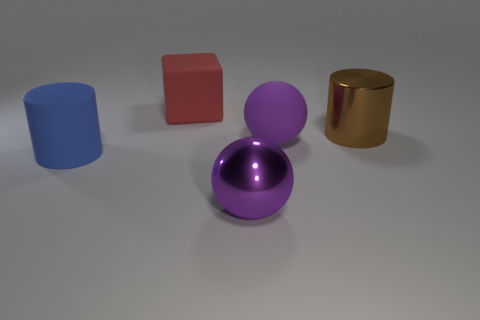Add 1 big blue matte objects. How many objects exist? 6 Subtract all balls. How many objects are left? 3 Add 3 blue things. How many blue things are left? 4 Add 2 matte objects. How many matte objects exist? 5 Subtract 0 red cylinders. How many objects are left? 5 Subtract all green things. Subtract all red things. How many objects are left? 4 